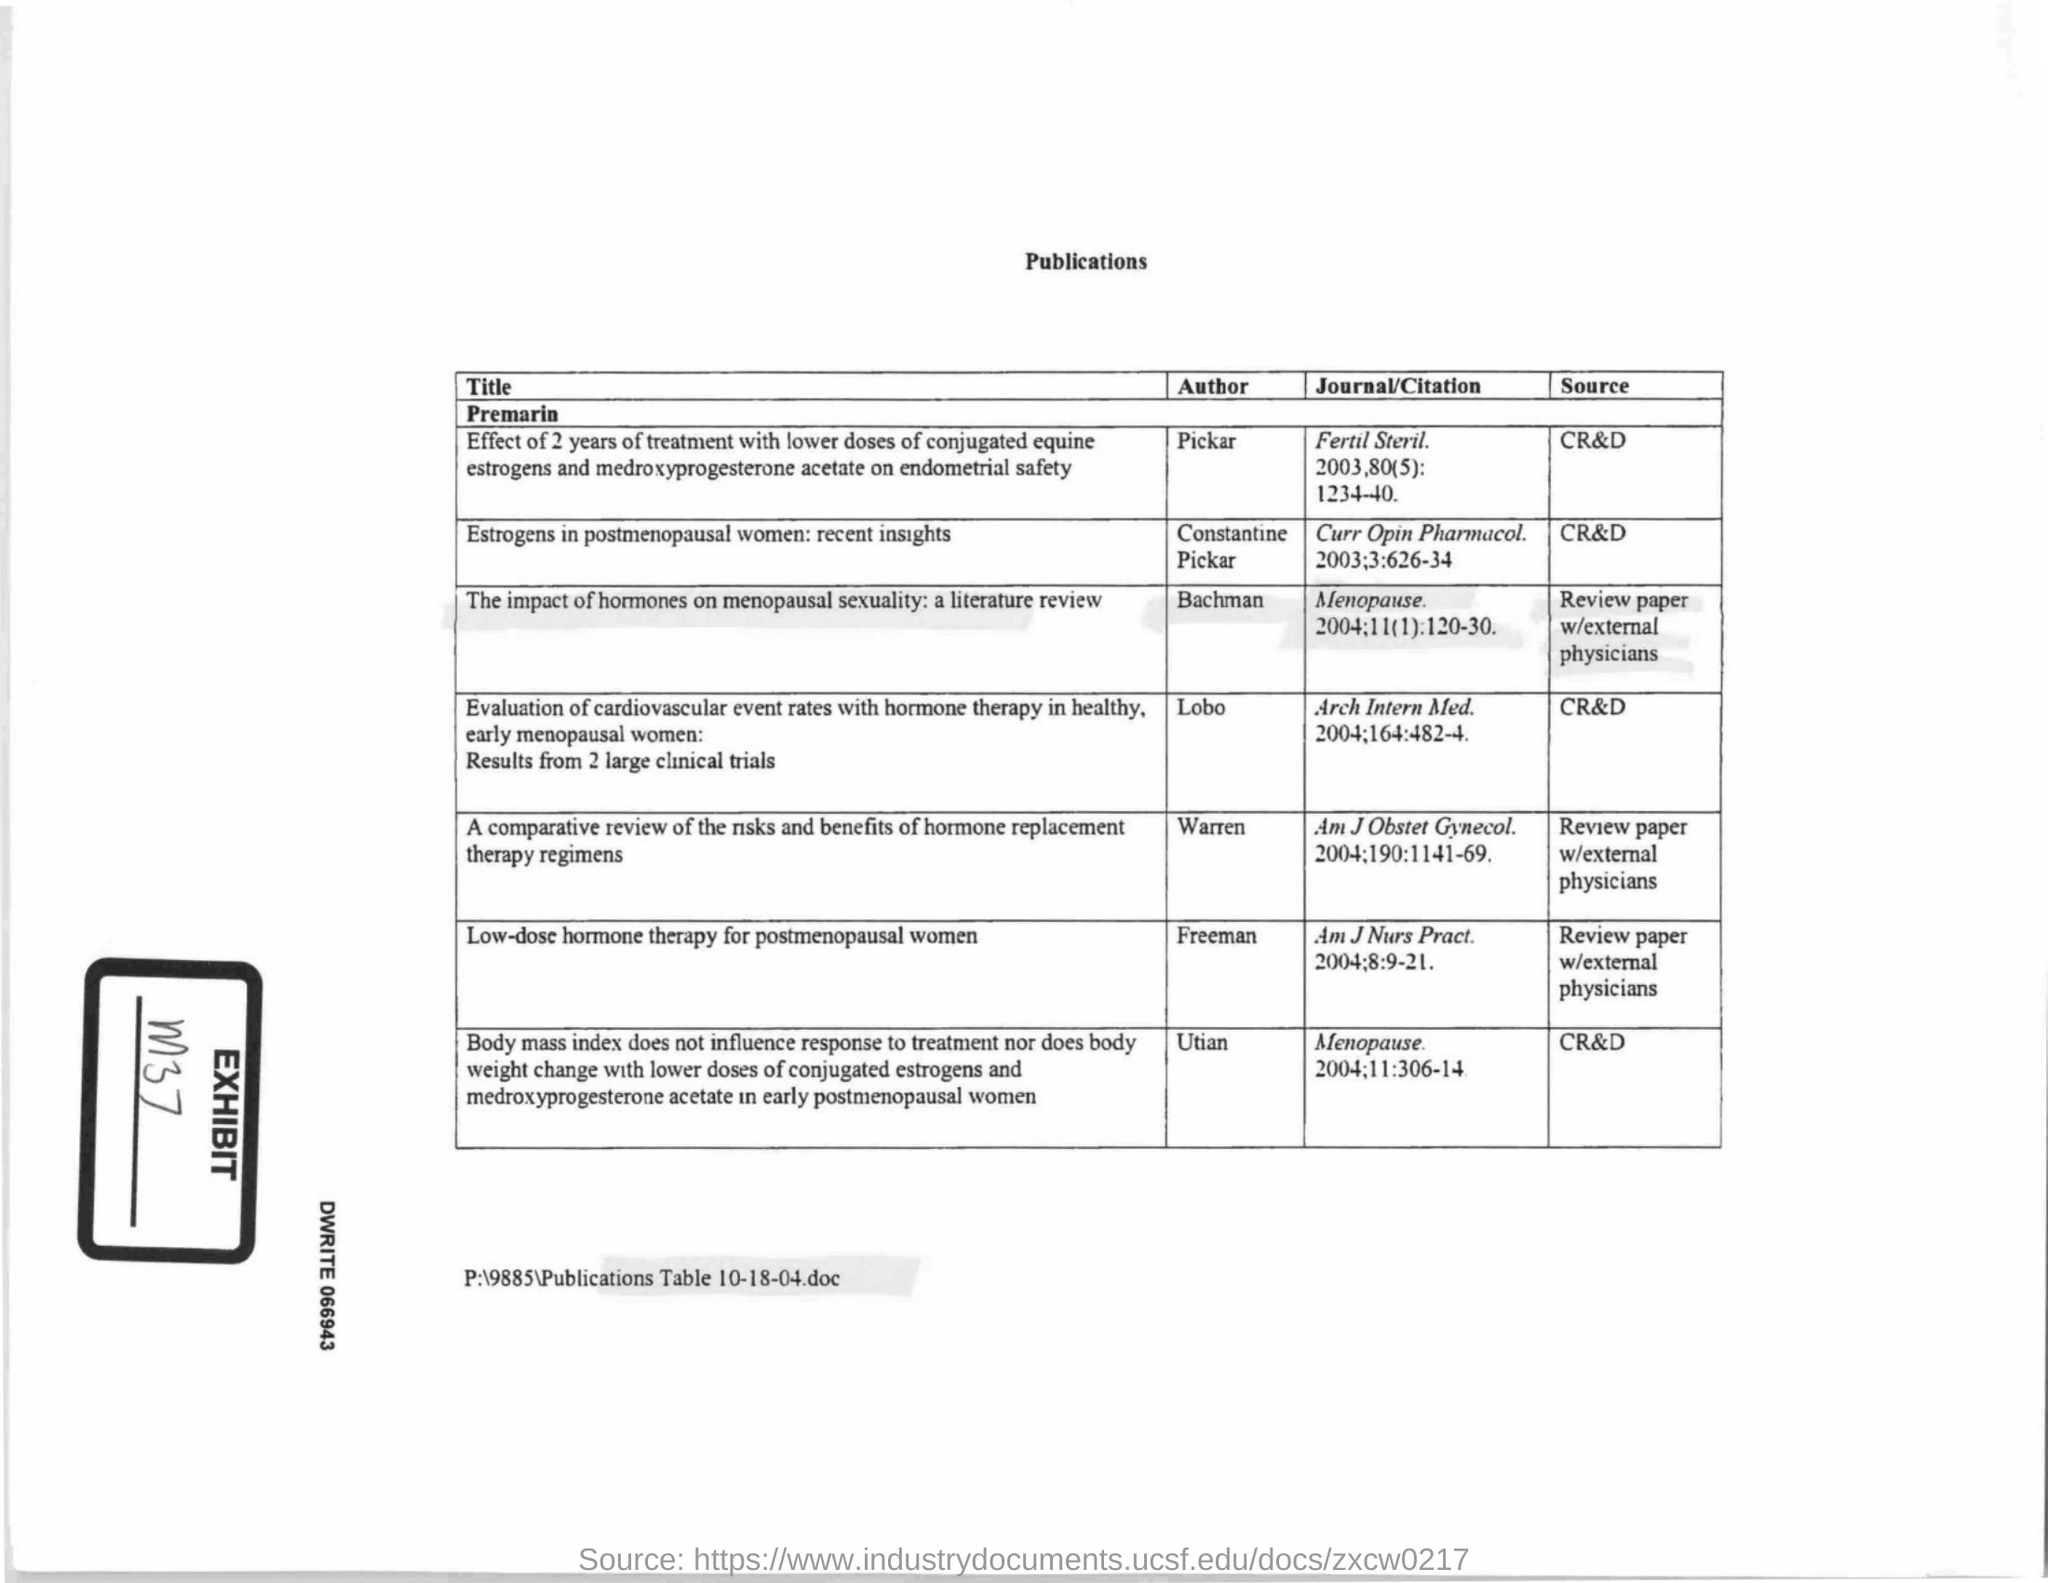What is the Exhibit No mentioned in the document?
Keep it short and to the point. M37. Who is the author of the paper titled 'Low-dose hormone therapy for postmenopausal women'?
Your response must be concise. FREEMAN. Who are the authors of the article titled 'Estrogens in postmenopausal women: recent insights'?
Keep it short and to the point. Constantine, Pickar. 